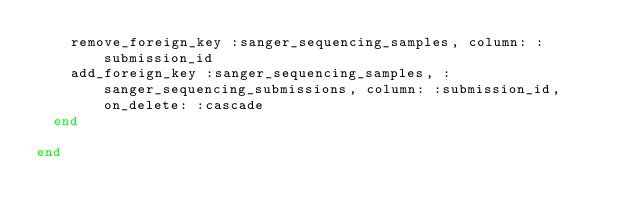Convert code to text. <code><loc_0><loc_0><loc_500><loc_500><_Ruby_>    remove_foreign_key :sanger_sequencing_samples, column: :submission_id
    add_foreign_key :sanger_sequencing_samples, :sanger_sequencing_submissions, column: :submission_id, on_delete: :cascade
  end

end
</code> 